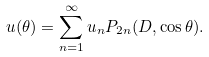<formula> <loc_0><loc_0><loc_500><loc_500>u ( \theta ) = \sum _ { n = 1 } ^ { \infty } u _ { n } P _ { 2 n } ( D , \cos \theta ) .</formula> 